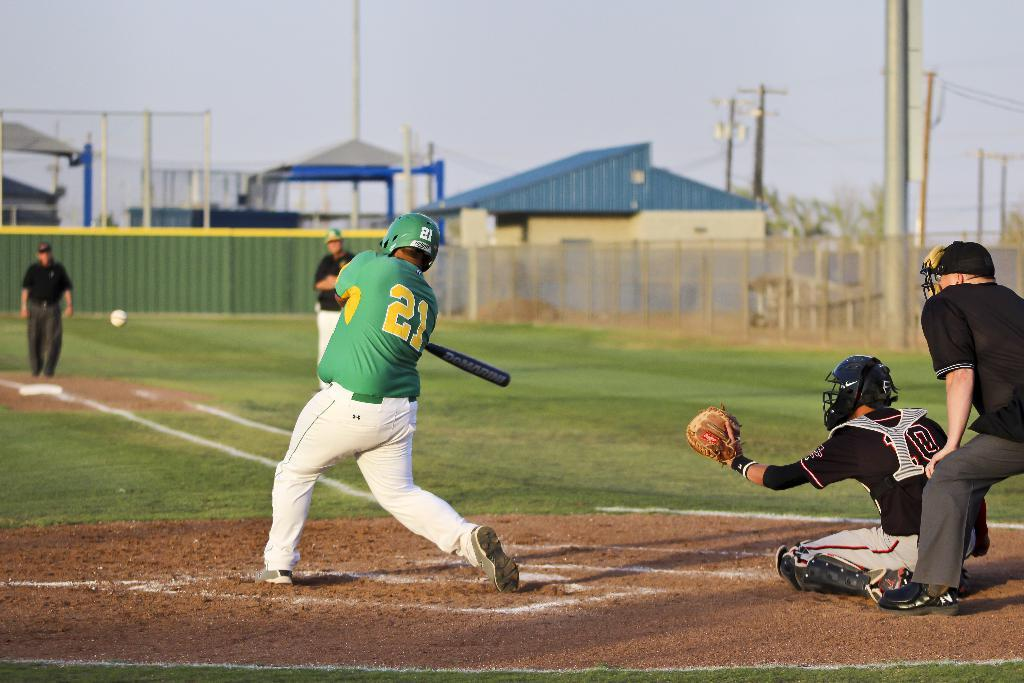<image>
Share a concise interpretation of the image provided. A baseball player in a green shirt with the number 21 on his back hits a ball. 